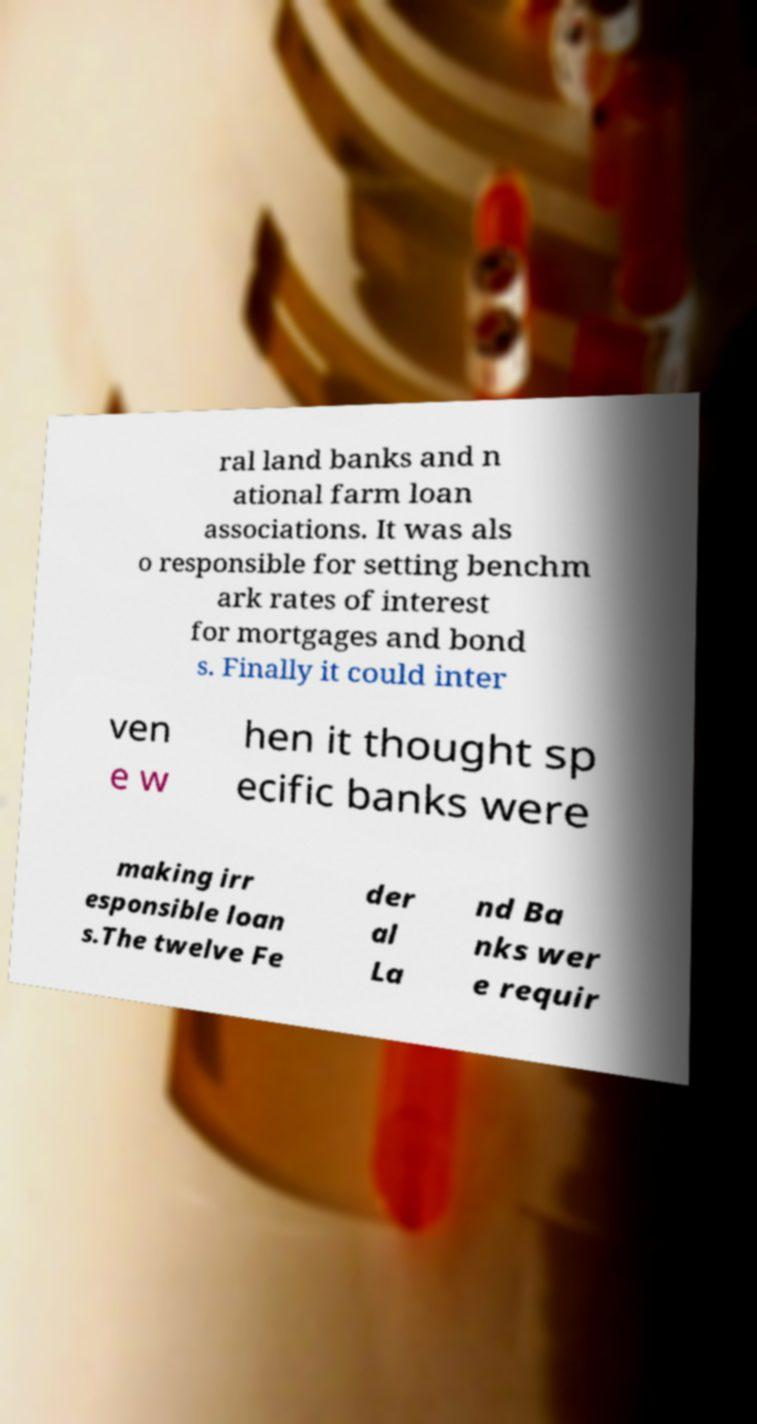What messages or text are displayed in this image? I need them in a readable, typed format. ral land banks and n ational farm loan associations. It was als o responsible for setting benchm ark rates of interest for mortgages and bond s. Finally it could inter ven e w hen it thought sp ecific banks were making irr esponsible loan s.The twelve Fe der al La nd Ba nks wer e requir 